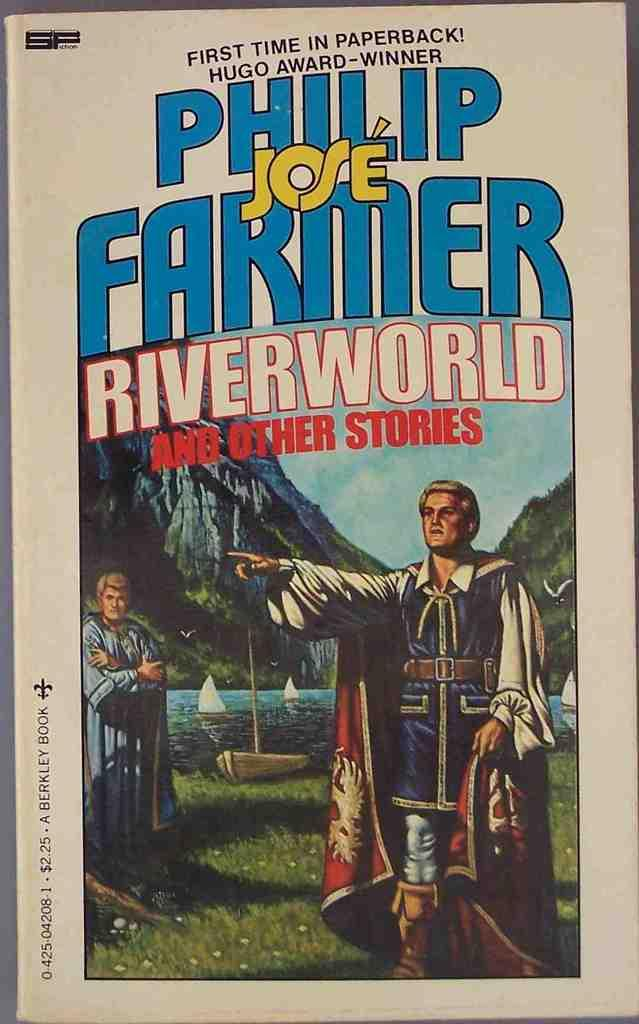Provide a one-sentence caption for the provided image. paperback copy of book named phillip jose farmer riverworld and other stories. 